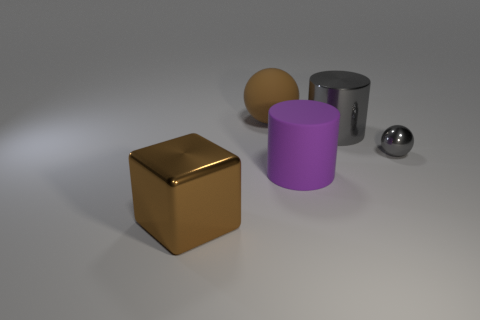Add 1 red matte cylinders. How many objects exist? 6 Subtract all cylinders. How many objects are left? 3 Add 5 large gray shiny cylinders. How many large gray shiny cylinders exist? 6 Subtract 0 yellow balls. How many objects are left? 5 Subtract all gray metal things. Subtract all metal objects. How many objects are left? 0 Add 2 big matte cylinders. How many big matte cylinders are left? 3 